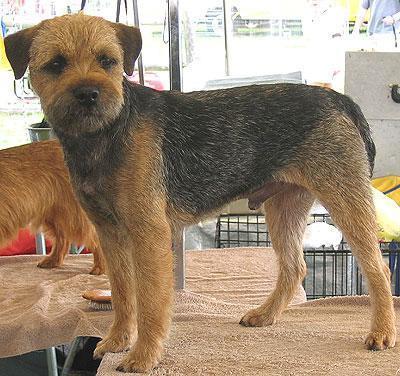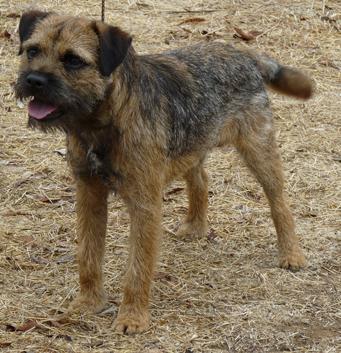The first image is the image on the left, the second image is the image on the right. For the images displayed, is the sentence "The left and right image contains the same number of dogs with at least one standing." factually correct? Answer yes or no. Yes. The first image is the image on the left, the second image is the image on the right. Given the left and right images, does the statement "The right image features one dog reclining on something soft and looking at the camera, and the left image shows a dog in an upright pose." hold true? Answer yes or no. No. 